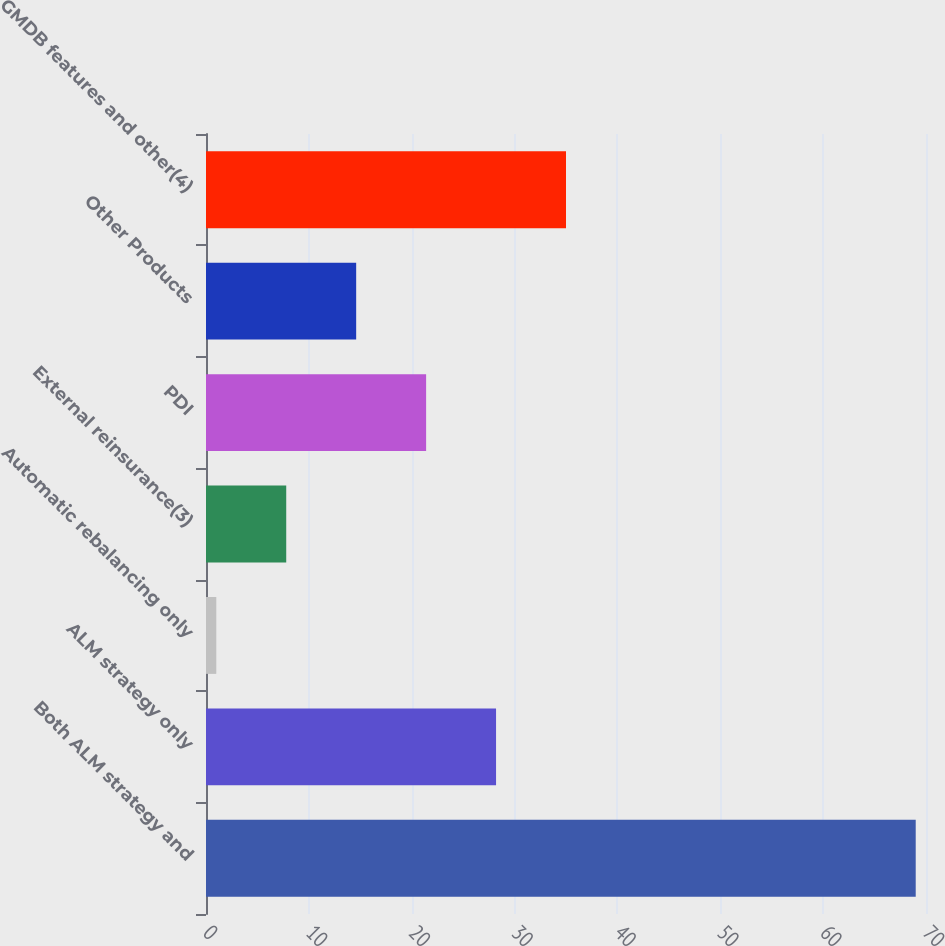Convert chart. <chart><loc_0><loc_0><loc_500><loc_500><bar_chart><fcel>Both ALM strategy and<fcel>ALM strategy only<fcel>Automatic rebalancing only<fcel>External reinsurance(3)<fcel>PDI<fcel>Other Products<fcel>GMDB features and other(4)<nl><fcel>69<fcel>28.2<fcel>1<fcel>7.8<fcel>21.4<fcel>14.6<fcel>35<nl></chart> 